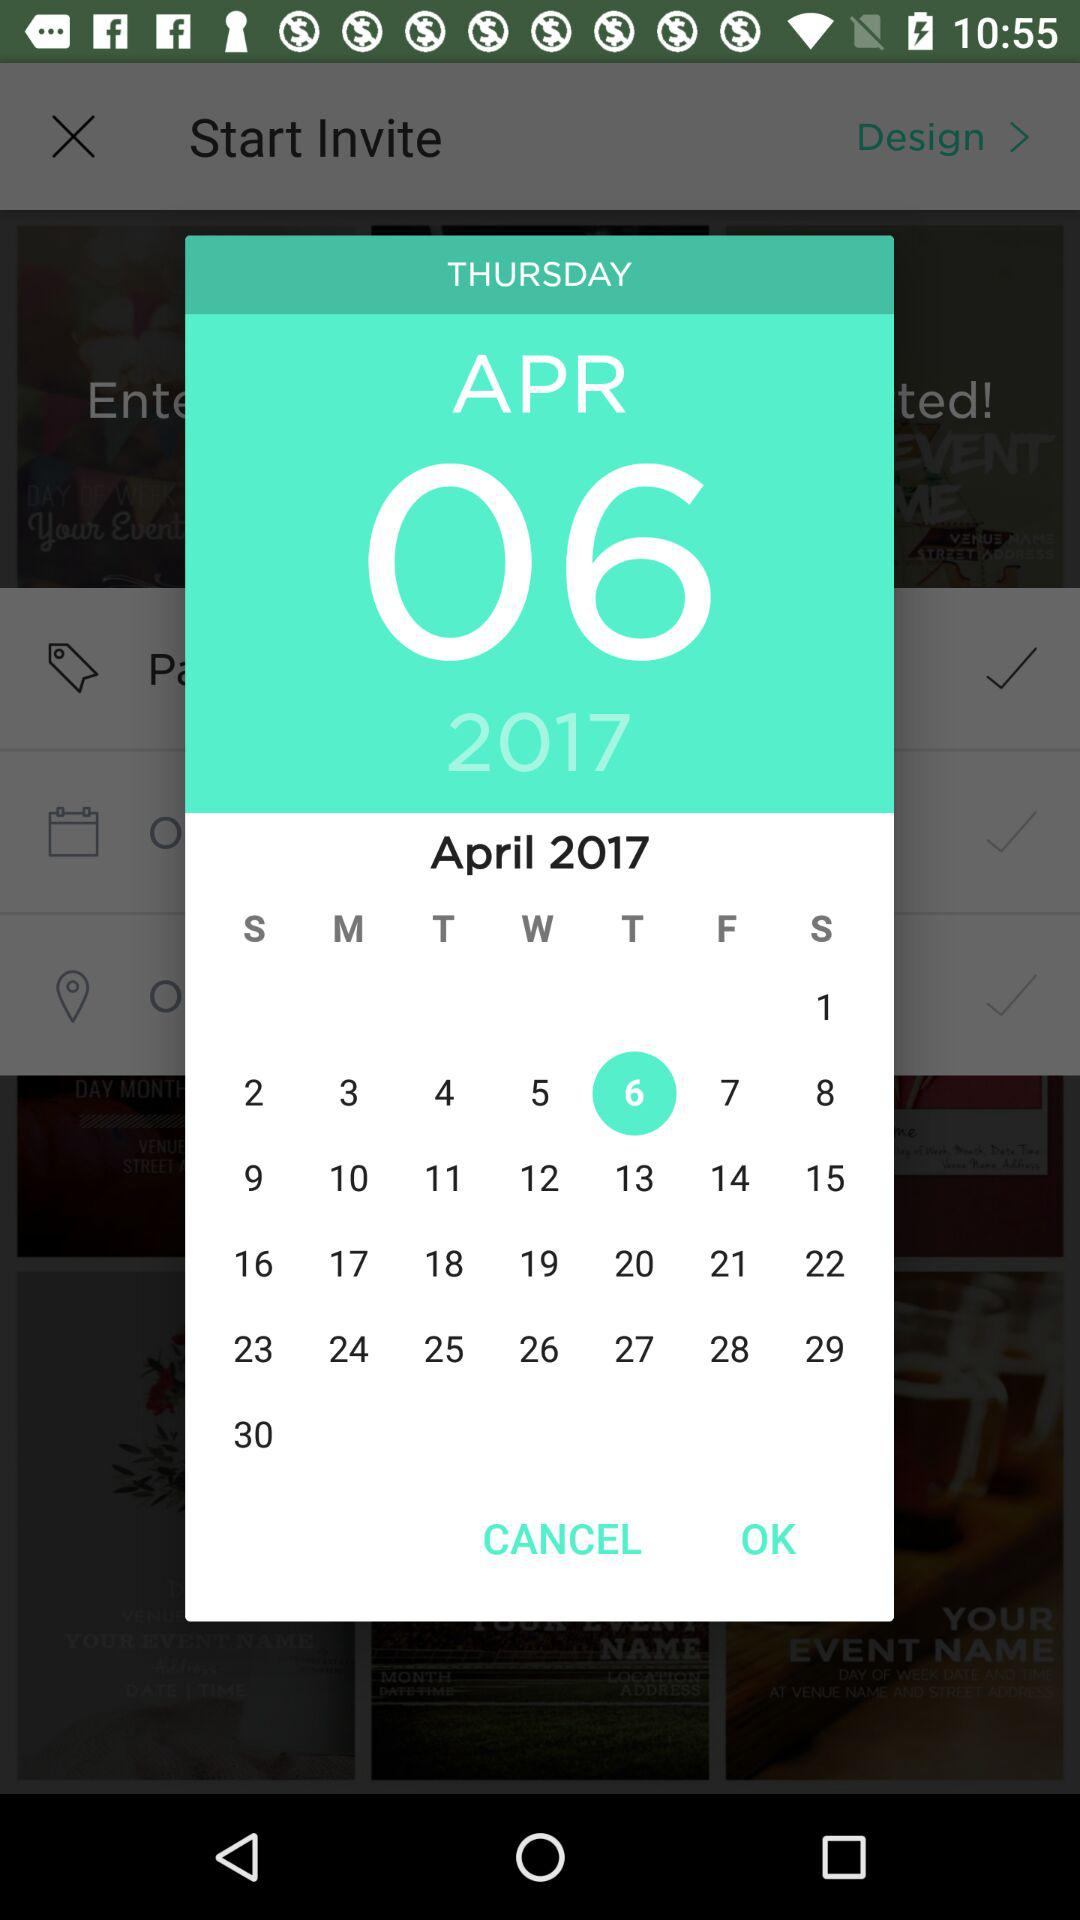Which location has been entered?
When the provided information is insufficient, respond with <no answer>. <no answer> 